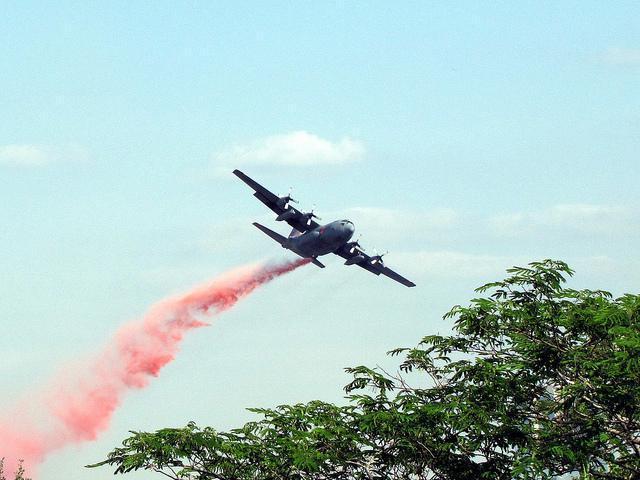How many engines does this plane have?
Give a very brief answer. 4. 